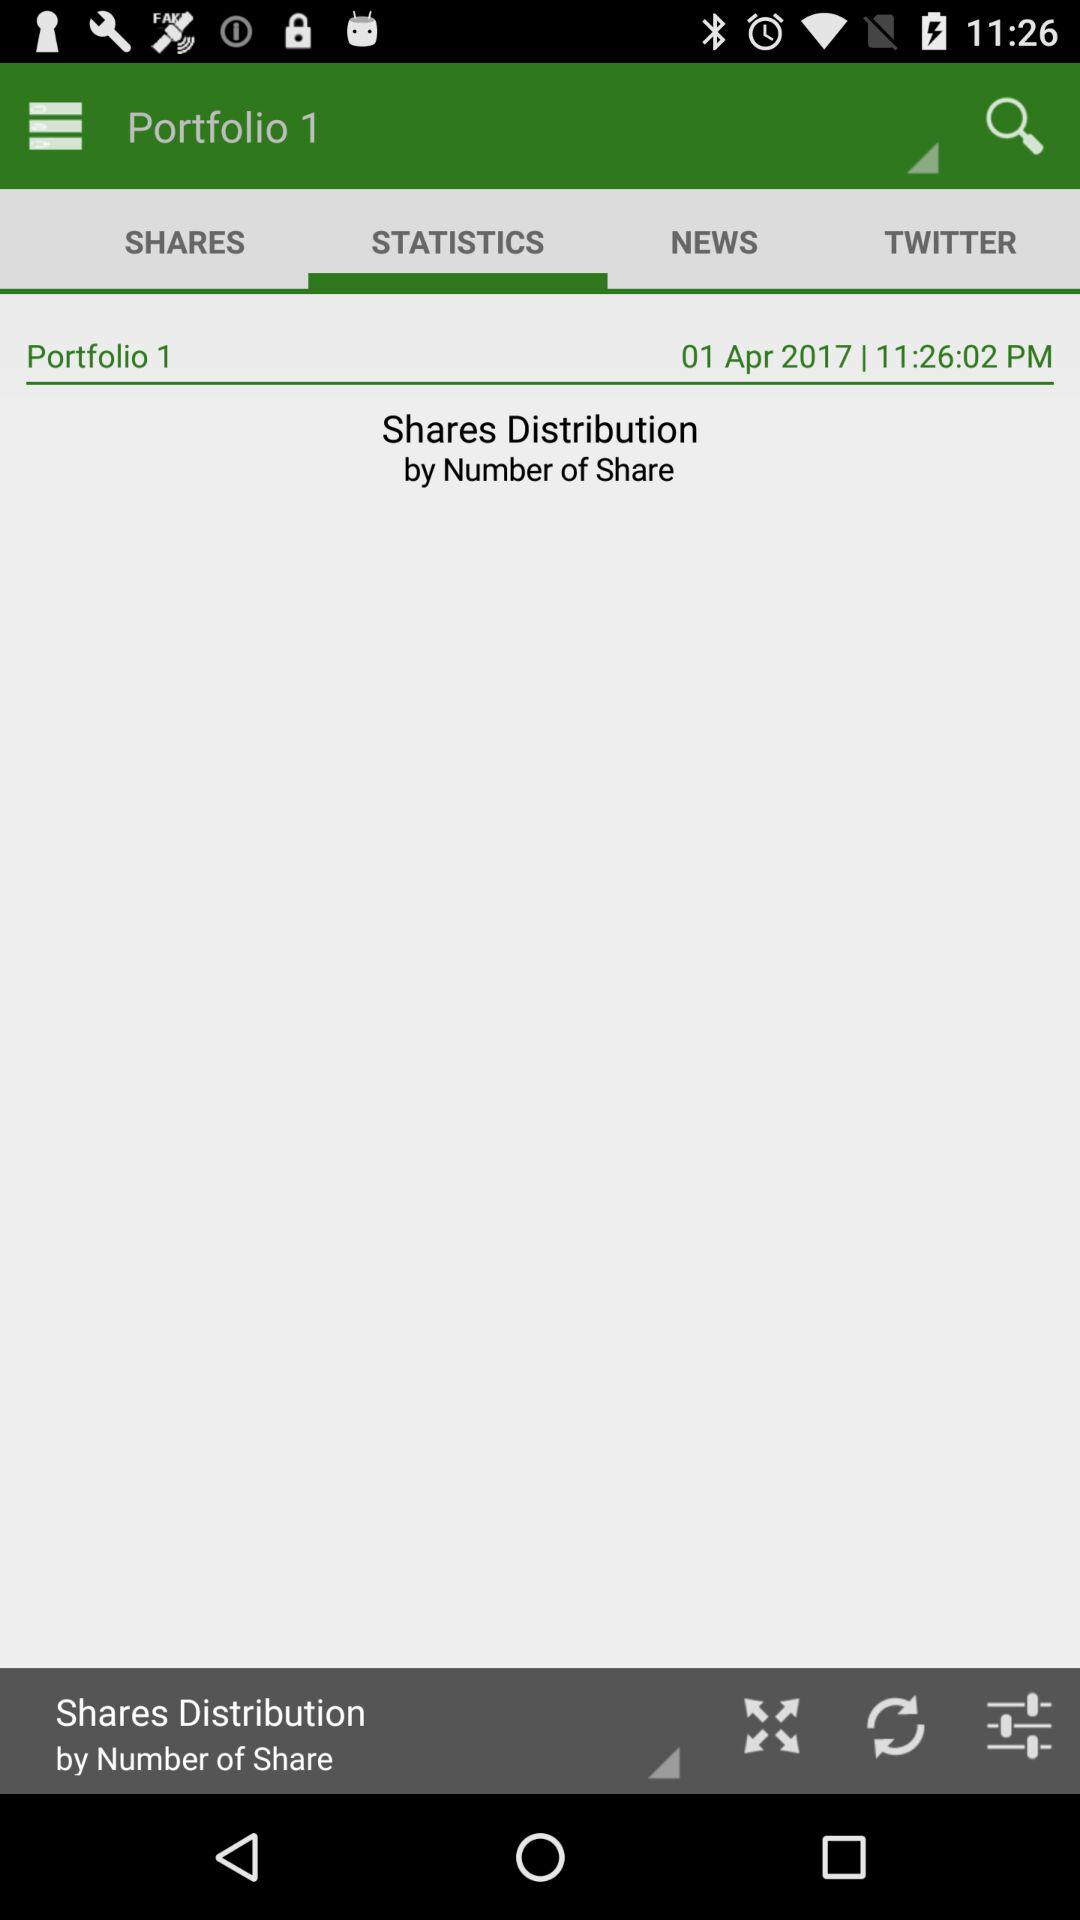How are shares distributed? Shares are distributed based on the number of shares. 